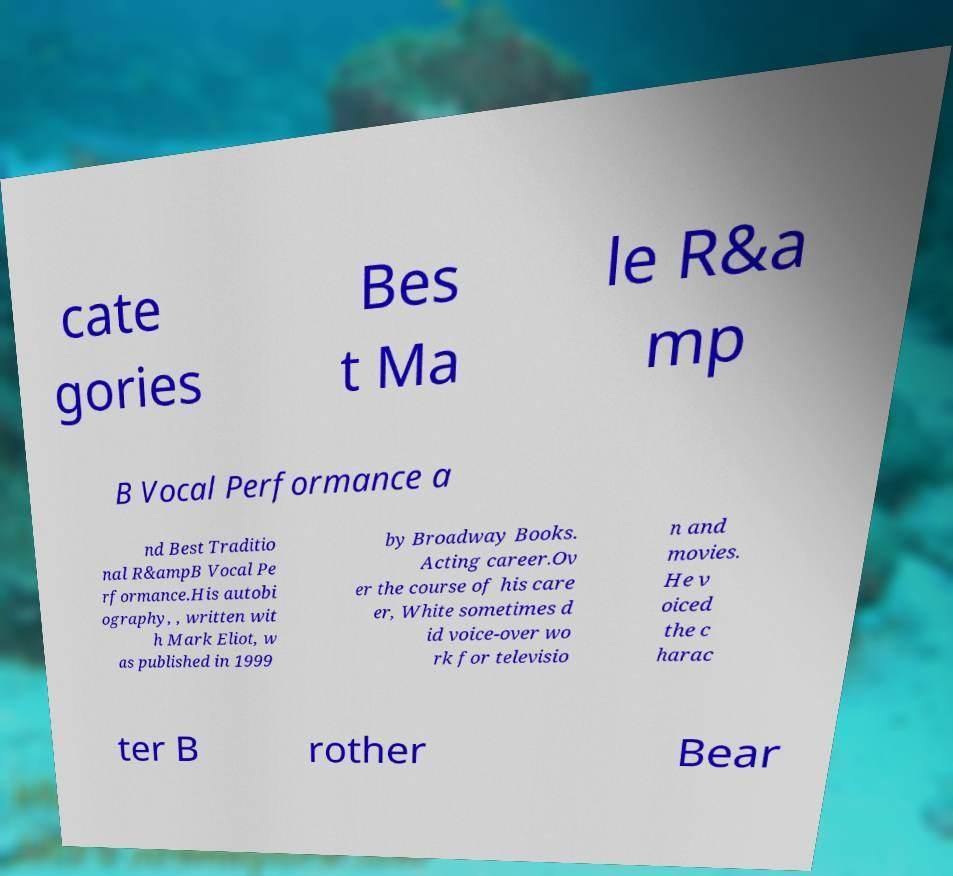Please identify and transcribe the text found in this image. cate gories Bes t Ma le R&a mp B Vocal Performance a nd Best Traditio nal R&ampB Vocal Pe rformance.His autobi ography, , written wit h Mark Eliot, w as published in 1999 by Broadway Books. Acting career.Ov er the course of his care er, White sometimes d id voice-over wo rk for televisio n and movies. He v oiced the c harac ter B rother Bear 